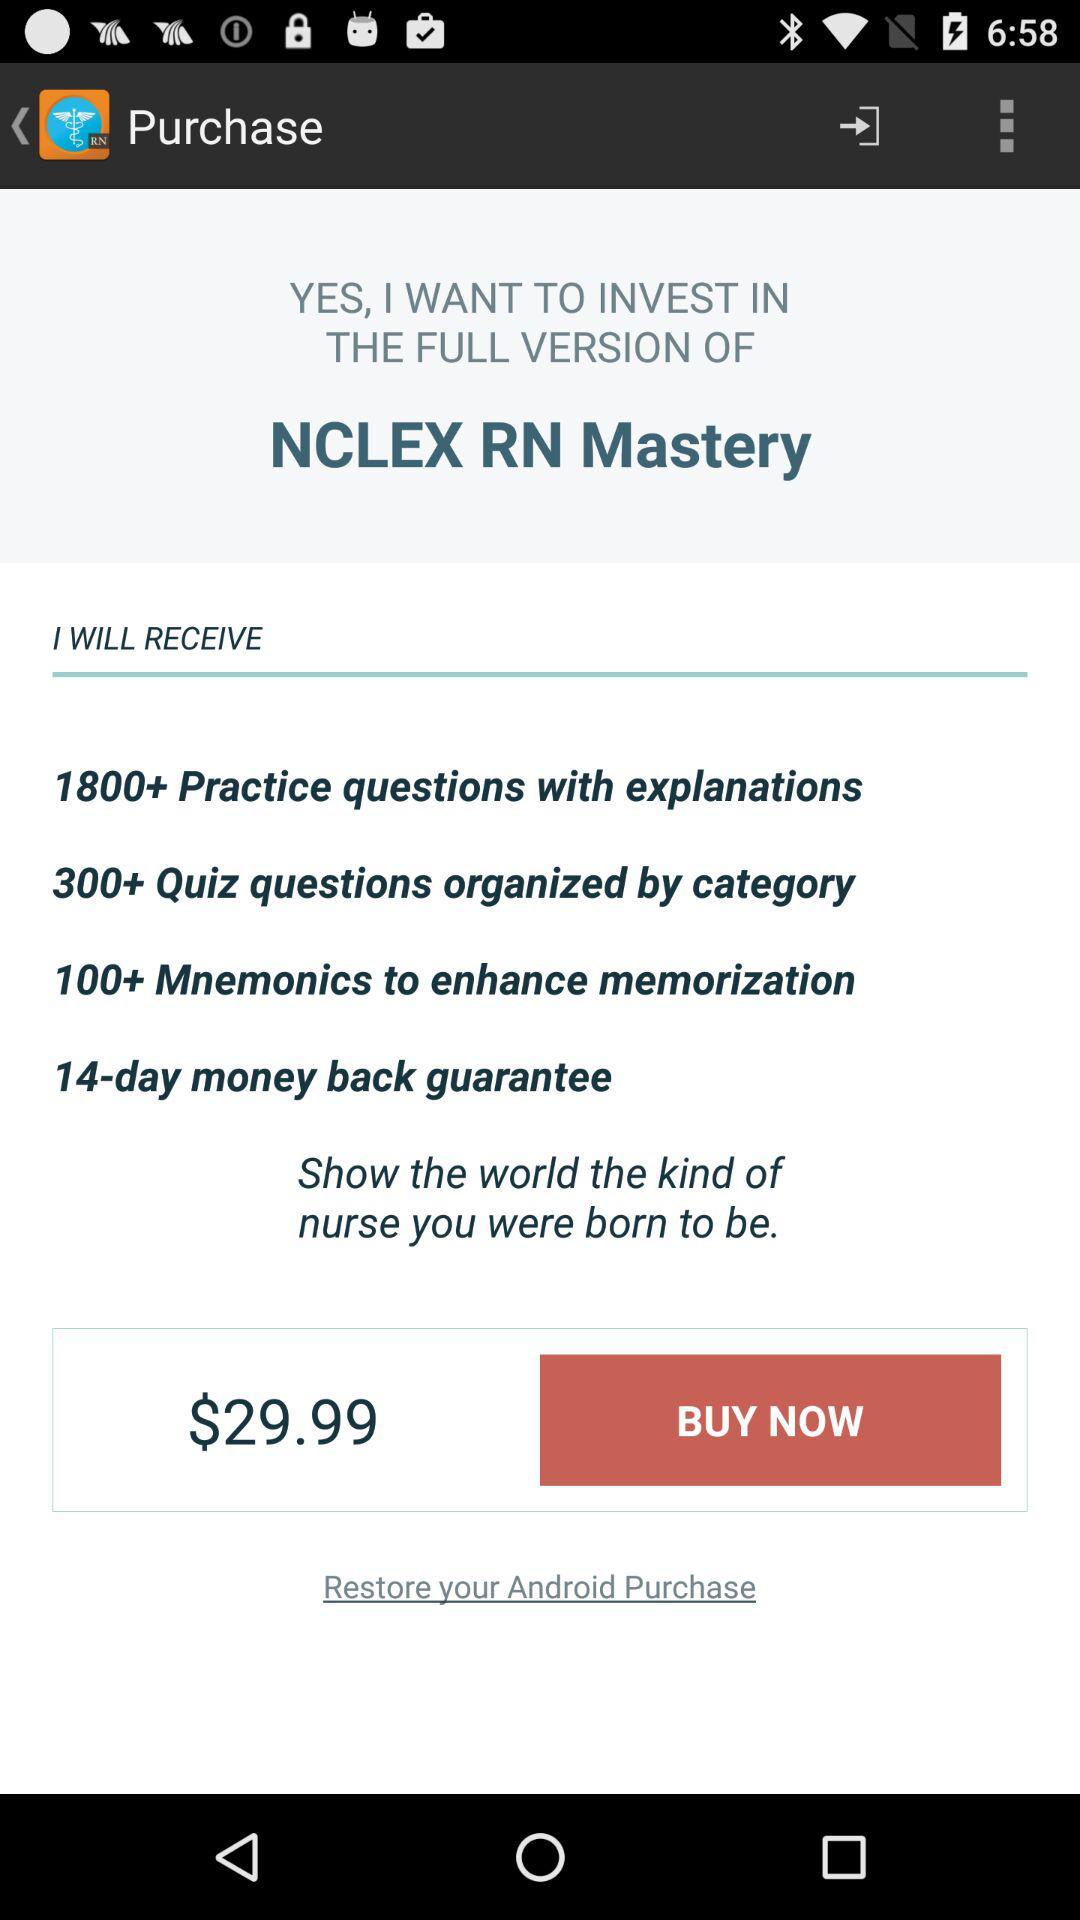What is the name of the application? The name of the application is "NCLEX RN Mastery". 